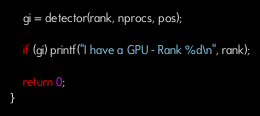Convert code to text. <code><loc_0><loc_0><loc_500><loc_500><_C++_>    gi = detector(rank, nprocs, pos);

    if (gi) printf("I have a GPU - Rank %d\n", rank);

    return 0;
}
</code> 